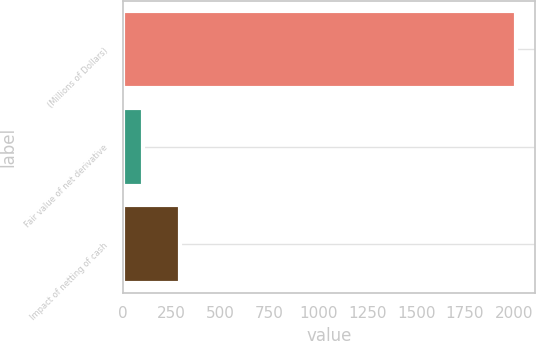Convert chart. <chart><loc_0><loc_0><loc_500><loc_500><bar_chart><fcel>(Millions of Dollars)<fcel>Fair value of net derivative<fcel>Impact of netting of cash<nl><fcel>2009<fcel>104<fcel>294.5<nl></chart> 